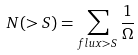<formula> <loc_0><loc_0><loc_500><loc_500>N ( > S ) = \sum _ { f l u x > S } \frac { 1 } { \Omega }</formula> 